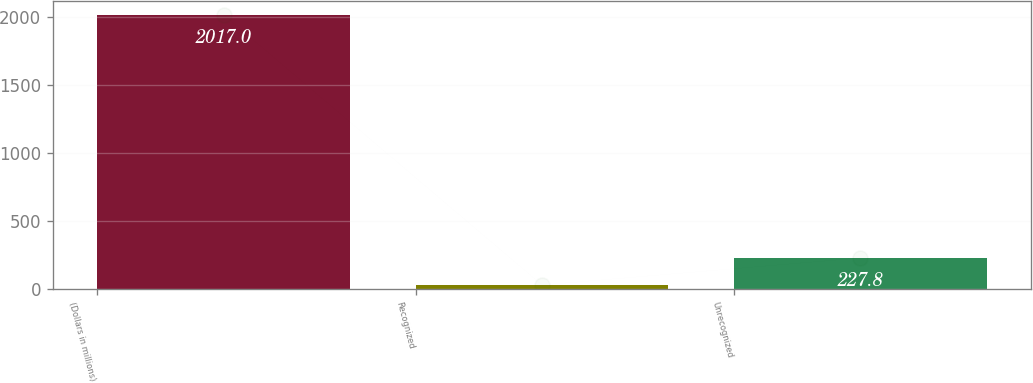<chart> <loc_0><loc_0><loc_500><loc_500><bar_chart><fcel>(Dollars in millions)<fcel>Recognized<fcel>Unrecognized<nl><fcel>2017<fcel>29<fcel>227.8<nl></chart> 